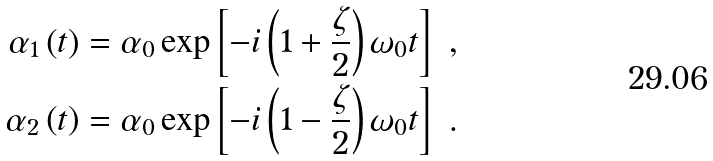Convert formula to latex. <formula><loc_0><loc_0><loc_500><loc_500>\alpha _ { 1 } \left ( t \right ) & = \alpha _ { 0 } \exp \left [ - i \left ( 1 + \frac { \zeta } { 2 } \right ) \omega _ { 0 } t \right ] \ , \\ \alpha _ { 2 } \left ( t \right ) & = \alpha _ { 0 } \exp \left [ - i \left ( 1 - \frac { \zeta } { 2 } \right ) \omega _ { 0 } t \right ] \ .</formula> 